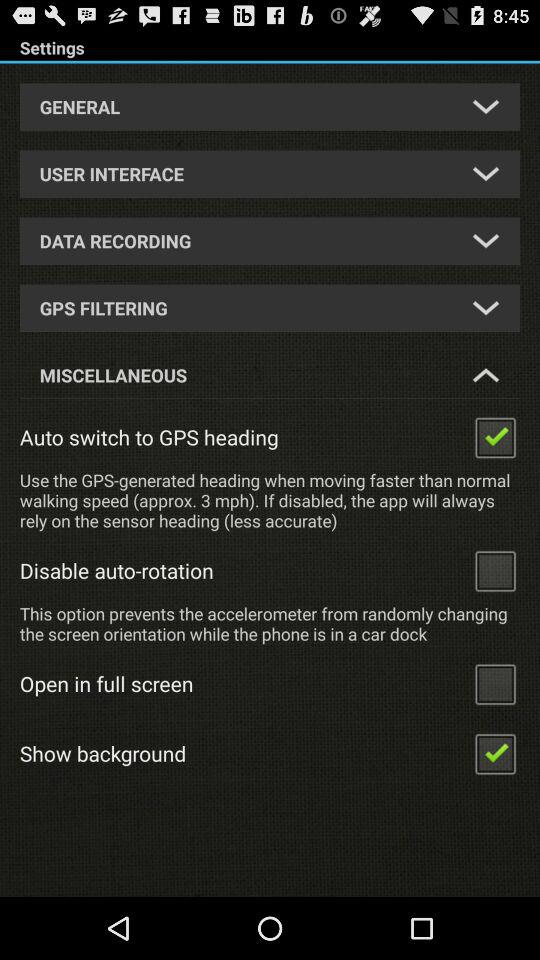What is the current status of "Auto switch to GPS heading"? The current status is "on". 